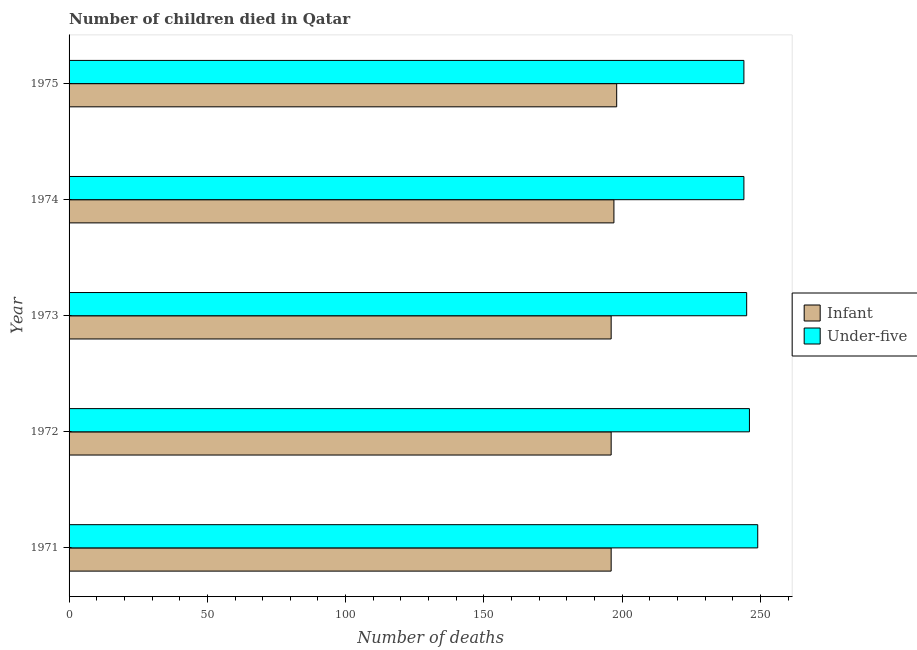How many groups of bars are there?
Make the answer very short. 5. What is the number of under-five deaths in 1975?
Provide a succinct answer. 244. Across all years, what is the maximum number of under-five deaths?
Provide a short and direct response. 249. Across all years, what is the minimum number of infant deaths?
Make the answer very short. 196. In which year was the number of under-five deaths minimum?
Your answer should be very brief. 1974. What is the total number of under-five deaths in the graph?
Your response must be concise. 1228. What is the difference between the number of infant deaths in 1974 and that in 1975?
Give a very brief answer. -1. What is the difference between the number of infant deaths in 1974 and the number of under-five deaths in 1971?
Keep it short and to the point. -52. What is the average number of infant deaths per year?
Make the answer very short. 196.6. In the year 1975, what is the difference between the number of infant deaths and number of under-five deaths?
Give a very brief answer. -46. In how many years, is the number of infant deaths greater than 60 ?
Give a very brief answer. 5. Is the number of infant deaths in 1974 less than that in 1975?
Provide a short and direct response. Yes. What is the difference between the highest and the second highest number of under-five deaths?
Provide a short and direct response. 3. What is the difference between the highest and the lowest number of under-five deaths?
Your answer should be very brief. 5. Is the sum of the number of infant deaths in 1974 and 1975 greater than the maximum number of under-five deaths across all years?
Give a very brief answer. Yes. What does the 1st bar from the top in 1974 represents?
Offer a very short reply. Under-five. What does the 2nd bar from the bottom in 1972 represents?
Your answer should be compact. Under-five. How many bars are there?
Your answer should be compact. 10. Are all the bars in the graph horizontal?
Give a very brief answer. Yes. How many years are there in the graph?
Ensure brevity in your answer.  5. What is the difference between two consecutive major ticks on the X-axis?
Offer a terse response. 50. Are the values on the major ticks of X-axis written in scientific E-notation?
Give a very brief answer. No. Does the graph contain any zero values?
Offer a terse response. No. Does the graph contain grids?
Keep it short and to the point. No. What is the title of the graph?
Provide a short and direct response. Number of children died in Qatar. What is the label or title of the X-axis?
Make the answer very short. Number of deaths. What is the Number of deaths of Infant in 1971?
Provide a short and direct response. 196. What is the Number of deaths in Under-five in 1971?
Give a very brief answer. 249. What is the Number of deaths of Infant in 1972?
Your response must be concise. 196. What is the Number of deaths in Under-five in 1972?
Provide a succinct answer. 246. What is the Number of deaths in Infant in 1973?
Make the answer very short. 196. What is the Number of deaths in Under-five in 1973?
Provide a short and direct response. 245. What is the Number of deaths of Infant in 1974?
Offer a terse response. 197. What is the Number of deaths in Under-five in 1974?
Offer a very short reply. 244. What is the Number of deaths in Infant in 1975?
Provide a succinct answer. 198. What is the Number of deaths of Under-five in 1975?
Ensure brevity in your answer.  244. Across all years, what is the maximum Number of deaths in Infant?
Your answer should be very brief. 198. Across all years, what is the maximum Number of deaths in Under-five?
Keep it short and to the point. 249. Across all years, what is the minimum Number of deaths in Infant?
Your response must be concise. 196. Across all years, what is the minimum Number of deaths in Under-five?
Give a very brief answer. 244. What is the total Number of deaths of Infant in the graph?
Your answer should be very brief. 983. What is the total Number of deaths in Under-five in the graph?
Give a very brief answer. 1228. What is the difference between the Number of deaths of Under-five in 1971 and that in 1972?
Ensure brevity in your answer.  3. What is the difference between the Number of deaths of Infant in 1971 and that in 1973?
Ensure brevity in your answer.  0. What is the difference between the Number of deaths of Under-five in 1971 and that in 1973?
Provide a short and direct response. 4. What is the difference between the Number of deaths of Under-five in 1971 and that in 1974?
Your response must be concise. 5. What is the difference between the Number of deaths in Infant in 1971 and that in 1975?
Offer a very short reply. -2. What is the difference between the Number of deaths of Under-five in 1971 and that in 1975?
Give a very brief answer. 5. What is the difference between the Number of deaths of Infant in 1972 and that in 1974?
Your answer should be very brief. -1. What is the difference between the Number of deaths of Infant in 1972 and that in 1975?
Give a very brief answer. -2. What is the difference between the Number of deaths in Infant in 1973 and that in 1975?
Your answer should be very brief. -2. What is the difference between the Number of deaths in Under-five in 1974 and that in 1975?
Your response must be concise. 0. What is the difference between the Number of deaths in Infant in 1971 and the Number of deaths in Under-five in 1973?
Your answer should be very brief. -49. What is the difference between the Number of deaths in Infant in 1971 and the Number of deaths in Under-five in 1974?
Keep it short and to the point. -48. What is the difference between the Number of deaths of Infant in 1971 and the Number of deaths of Under-five in 1975?
Provide a short and direct response. -48. What is the difference between the Number of deaths in Infant in 1972 and the Number of deaths in Under-five in 1973?
Keep it short and to the point. -49. What is the difference between the Number of deaths in Infant in 1972 and the Number of deaths in Under-five in 1974?
Provide a succinct answer. -48. What is the difference between the Number of deaths of Infant in 1972 and the Number of deaths of Under-five in 1975?
Offer a terse response. -48. What is the difference between the Number of deaths in Infant in 1973 and the Number of deaths in Under-five in 1974?
Give a very brief answer. -48. What is the difference between the Number of deaths in Infant in 1973 and the Number of deaths in Under-five in 1975?
Provide a succinct answer. -48. What is the difference between the Number of deaths in Infant in 1974 and the Number of deaths in Under-five in 1975?
Your response must be concise. -47. What is the average Number of deaths in Infant per year?
Your answer should be very brief. 196.6. What is the average Number of deaths in Under-five per year?
Offer a very short reply. 245.6. In the year 1971, what is the difference between the Number of deaths of Infant and Number of deaths of Under-five?
Provide a short and direct response. -53. In the year 1972, what is the difference between the Number of deaths in Infant and Number of deaths in Under-five?
Offer a terse response. -50. In the year 1973, what is the difference between the Number of deaths of Infant and Number of deaths of Under-five?
Offer a very short reply. -49. In the year 1974, what is the difference between the Number of deaths in Infant and Number of deaths in Under-five?
Provide a short and direct response. -47. In the year 1975, what is the difference between the Number of deaths of Infant and Number of deaths of Under-five?
Your answer should be very brief. -46. What is the ratio of the Number of deaths of Infant in 1971 to that in 1972?
Your answer should be very brief. 1. What is the ratio of the Number of deaths in Under-five in 1971 to that in 1972?
Make the answer very short. 1.01. What is the ratio of the Number of deaths in Infant in 1971 to that in 1973?
Make the answer very short. 1. What is the ratio of the Number of deaths of Under-five in 1971 to that in 1973?
Your response must be concise. 1.02. What is the ratio of the Number of deaths of Infant in 1971 to that in 1974?
Ensure brevity in your answer.  0.99. What is the ratio of the Number of deaths of Under-five in 1971 to that in 1974?
Ensure brevity in your answer.  1.02. What is the ratio of the Number of deaths of Under-five in 1971 to that in 1975?
Your answer should be very brief. 1.02. What is the ratio of the Number of deaths of Under-five in 1972 to that in 1974?
Give a very brief answer. 1.01. What is the ratio of the Number of deaths in Under-five in 1972 to that in 1975?
Your answer should be compact. 1.01. What is the ratio of the Number of deaths of Under-five in 1974 to that in 1975?
Give a very brief answer. 1. What is the difference between the highest and the second highest Number of deaths in Under-five?
Your answer should be compact. 3. What is the difference between the highest and the lowest Number of deaths in Infant?
Make the answer very short. 2. 